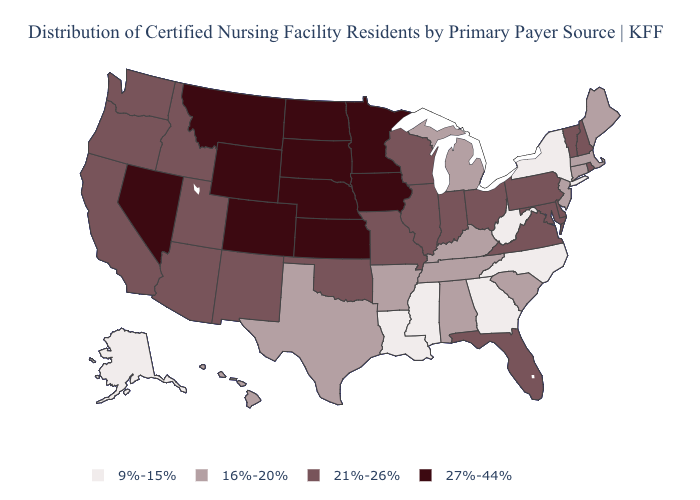Name the states that have a value in the range 27%-44%?
Be succinct. Colorado, Iowa, Kansas, Minnesota, Montana, Nebraska, Nevada, North Dakota, South Dakota, Wyoming. What is the value of Florida?
Concise answer only. 21%-26%. Name the states that have a value in the range 16%-20%?
Write a very short answer. Alabama, Arkansas, Connecticut, Hawaii, Kentucky, Maine, Massachusetts, Michigan, New Jersey, South Carolina, Tennessee, Texas. Among the states that border Delaware , which have the highest value?
Concise answer only. Maryland, Pennsylvania. What is the lowest value in states that border California?
Keep it brief. 21%-26%. What is the value of South Carolina?
Short answer required. 16%-20%. What is the value of Arkansas?
Quick response, please. 16%-20%. Name the states that have a value in the range 16%-20%?
Give a very brief answer. Alabama, Arkansas, Connecticut, Hawaii, Kentucky, Maine, Massachusetts, Michigan, New Jersey, South Carolina, Tennessee, Texas. How many symbols are there in the legend?
Give a very brief answer. 4. Among the states that border Montana , does South Dakota have the highest value?
Write a very short answer. Yes. Does Kentucky have the lowest value in the South?
Concise answer only. No. Among the states that border Mississippi , which have the lowest value?
Be succinct. Louisiana. Name the states that have a value in the range 9%-15%?
Short answer required. Alaska, Georgia, Louisiana, Mississippi, New York, North Carolina, West Virginia. Name the states that have a value in the range 9%-15%?
Quick response, please. Alaska, Georgia, Louisiana, Mississippi, New York, North Carolina, West Virginia. Does Michigan have a lower value than Kentucky?
Answer briefly. No. 